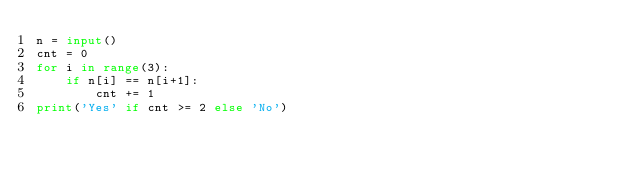<code> <loc_0><loc_0><loc_500><loc_500><_Python_>n = input()
cnt = 0
for i in range(3):
    if n[i] == n[i+1]:
        cnt += 1
print('Yes' if cnt >= 2 else 'No')</code> 